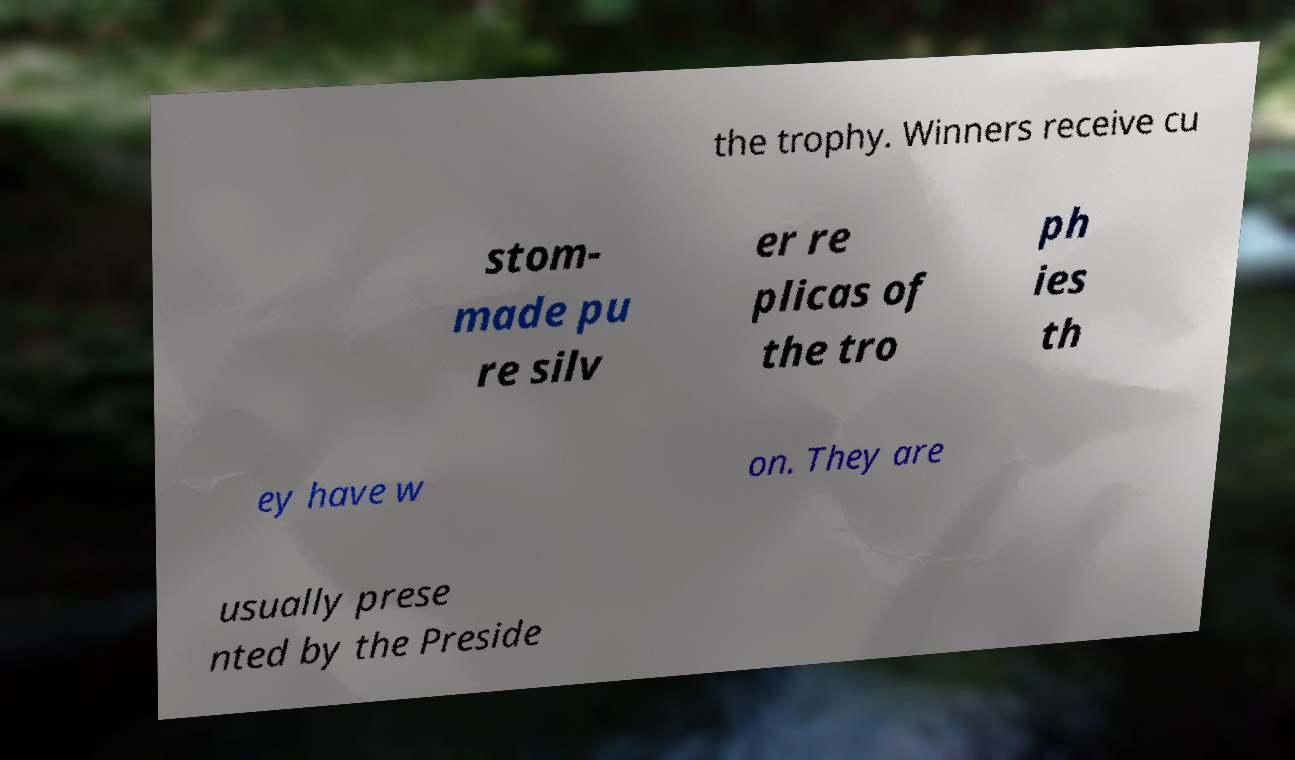For documentation purposes, I need the text within this image transcribed. Could you provide that? the trophy. Winners receive cu stom- made pu re silv er re plicas of the tro ph ies th ey have w on. They are usually prese nted by the Preside 